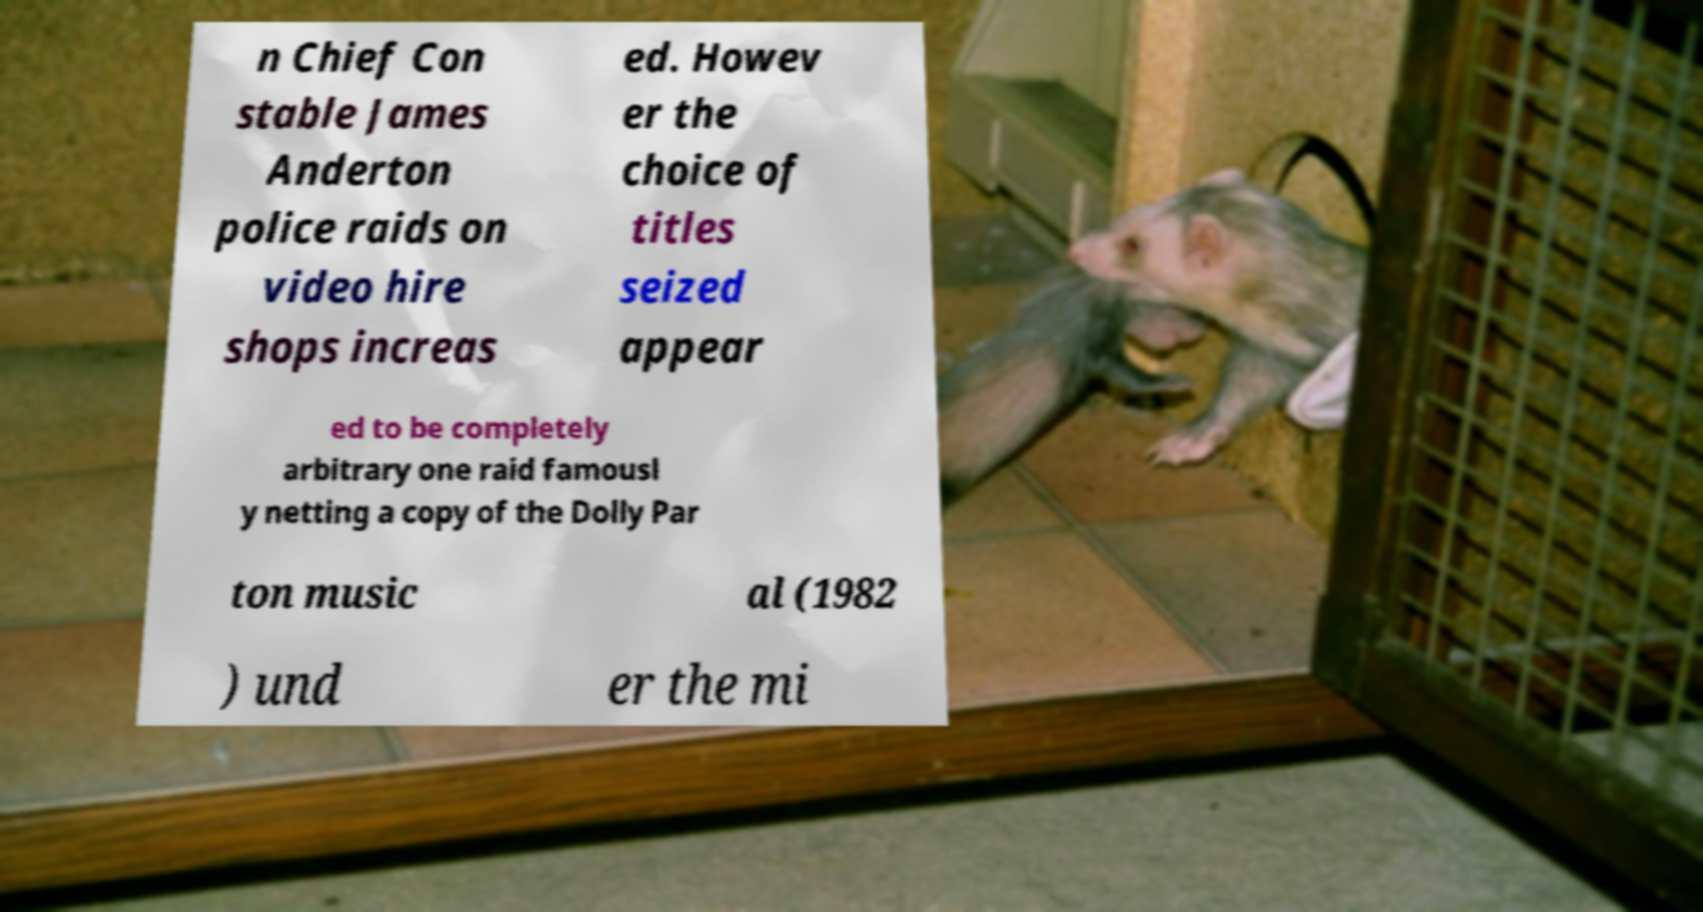Could you extract and type out the text from this image? n Chief Con stable James Anderton police raids on video hire shops increas ed. Howev er the choice of titles seized appear ed to be completely arbitrary one raid famousl y netting a copy of the Dolly Par ton music al (1982 ) und er the mi 